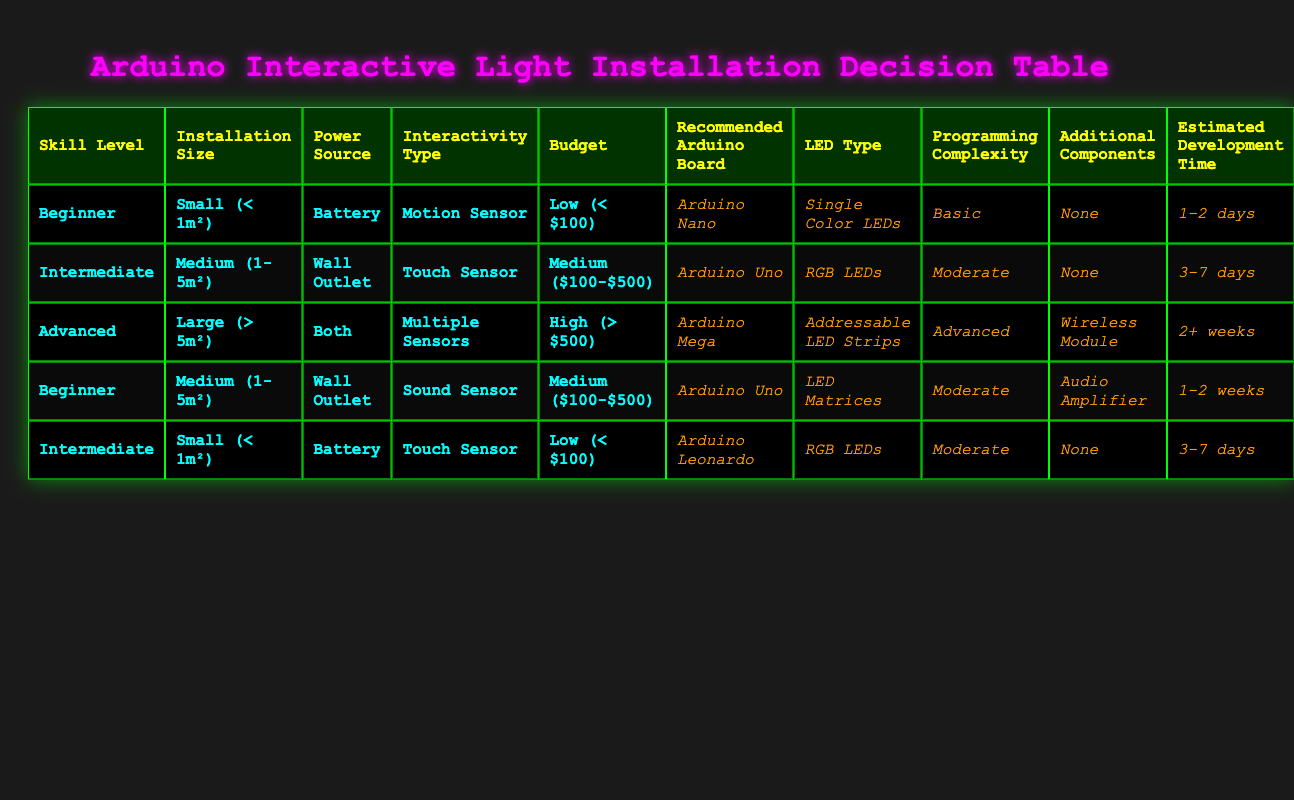What is the recommended Arduino board for beginners with a small installation using a battery? According to the table, for a beginner with a small installation size, a battery power source, and using a motion sensor with a low budget, the recommended Arduino board is the Arduino Nano.
Answer: Arduino Nano How many different types of interactivity are listed in the table? The table lists four types of interactivity: Motion Sensor, Touch Sensor, Sound Sensor, and Multiple Sensors. Therefore, there are four types of interactivity mentioned.
Answer: 4 Is it true that both the Arduino Uno and RGB LEDs are recommended for an intermediate user on a medium installation with a touch sensor and a medium budget? Yes, it is true. The table specifies that for an intermediate user, a medium installation, a touch sensor, and a medium budget, the recommended Arduino board is Arduino Uno and the LED type is RGB LEDs.
Answer: Yes What is the estimated development time for an advanced project with a large installation using multiple sensors and a high budget? The table indicates that for an advanced user with a large installation size, using multiple sensors, and a high budget, the estimated development time is 2 or more weeks.
Answer: 2+ weeks Which LED type is suggested for beginners working with a medium installation using a sound sensor and a medium budget? The table shows that for a beginner working with a medium installation size using a sound sensor and a medium budget, the suggested LED type is LED Matrices.
Answer: LED Matrices For which skill level is the Arduino Mega recommended when both power sources are available? The Arduino Mega is recommended for advanced users when both power sources are available, as indicated by the row listing an advanced skill level, large installation size, multiple sensors, and a high budget.
Answer: Advanced What is the total number of projects listed in the table? The table contains a total of five distinct project configurations based on the various conditions and recommended actions.
Answer: 5 Are there any projects that do not require additional components? Yes, there are two projects in the table that do not require additional components: one is for a beginner with a small installation using a motion sensor and a low budget; the other is for an intermediate user with a small installation using a touch sensor and a low budget.
Answer: Yes What is the difference in estimated development time between the project for an advanced user and a beginner project? The advanced project requires 2+ weeks while the beginner project requires 1-2 days. The difference is at least 12 days, since 2+ weeks equates to more than 14 days when considered in a minimum estimation.
Answer: 12 days 